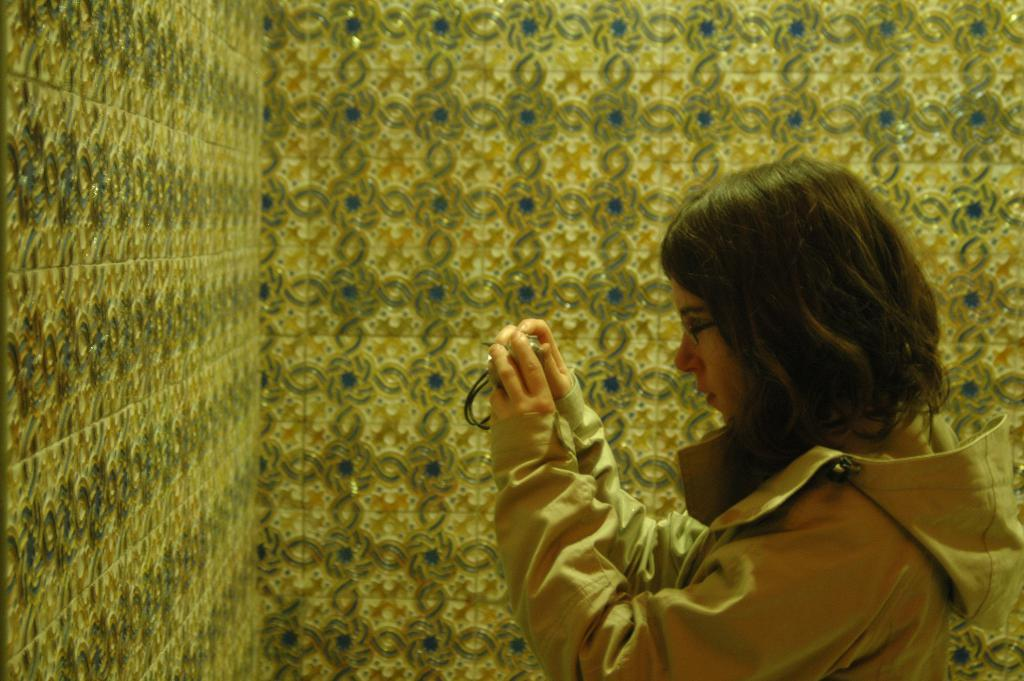What is the main subject of the image? There is a person in the image. What is the person wearing? The person is wearing goggles. What is the person holding? The person is holding a camera. What can be seen in the background of the image? There is a wall visible in the image. How much salt is present on the person's camera in the image? There is no salt present on the person's camera in the image. What arithmetic problem is the person solving in the image? There is no indication of the person solving an arithmetic problem in the image. 